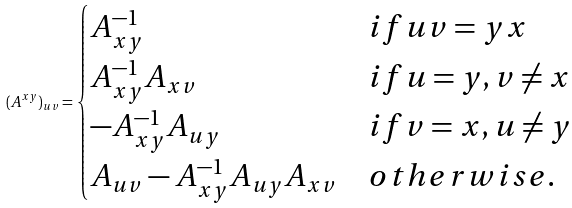<formula> <loc_0><loc_0><loc_500><loc_500>( A ^ { x y } ) _ { u v } = \begin{cases} A _ { x y } ^ { - 1 } \quad & i f u v = y x \\ A _ { x y } ^ { - 1 } A _ { x v } & i f u = y , v \neq x \\ - A _ { x y } ^ { - 1 } A _ { u y } & i f v = x , u \neq y \\ A _ { u v } - A _ { x y } ^ { - 1 } A _ { u y } A _ { x v } & o t h e r w i s e . \end{cases}</formula> 